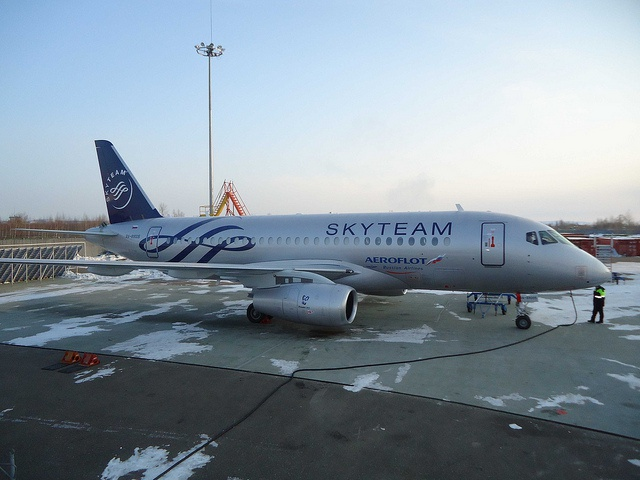Describe the objects in this image and their specific colors. I can see airplane in lightblue, gray, and navy tones, people in lightblue, black, gray, green, and white tones, and people in lightblue, gray, black, and darkblue tones in this image. 